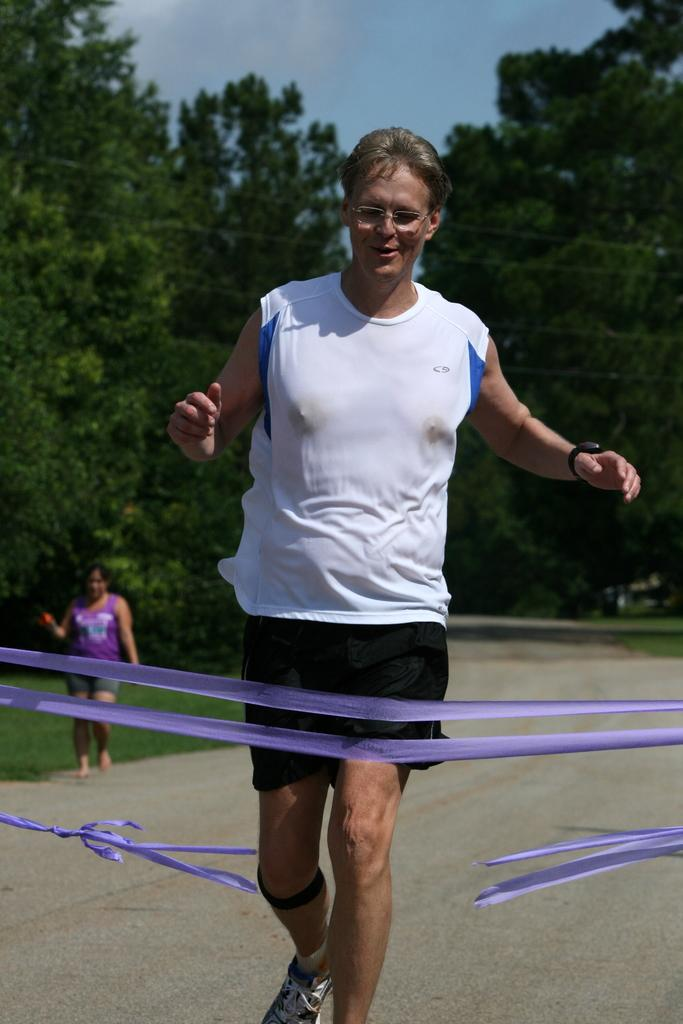Who is present in the image? There is a man in the image. What is in front of the man? There are ribbons in front of the man. Can you describe the background of the image? In the background of the image, there is a person on the ground and trees are visible. The sky is also visible in the background. What type of neck ornament is the man wearing in the image? The man is not wearing any neck ornament in the image. Is there a baseball game happening in the background of the image? There is no indication of a baseball game or any baseball-related elements in the image. 